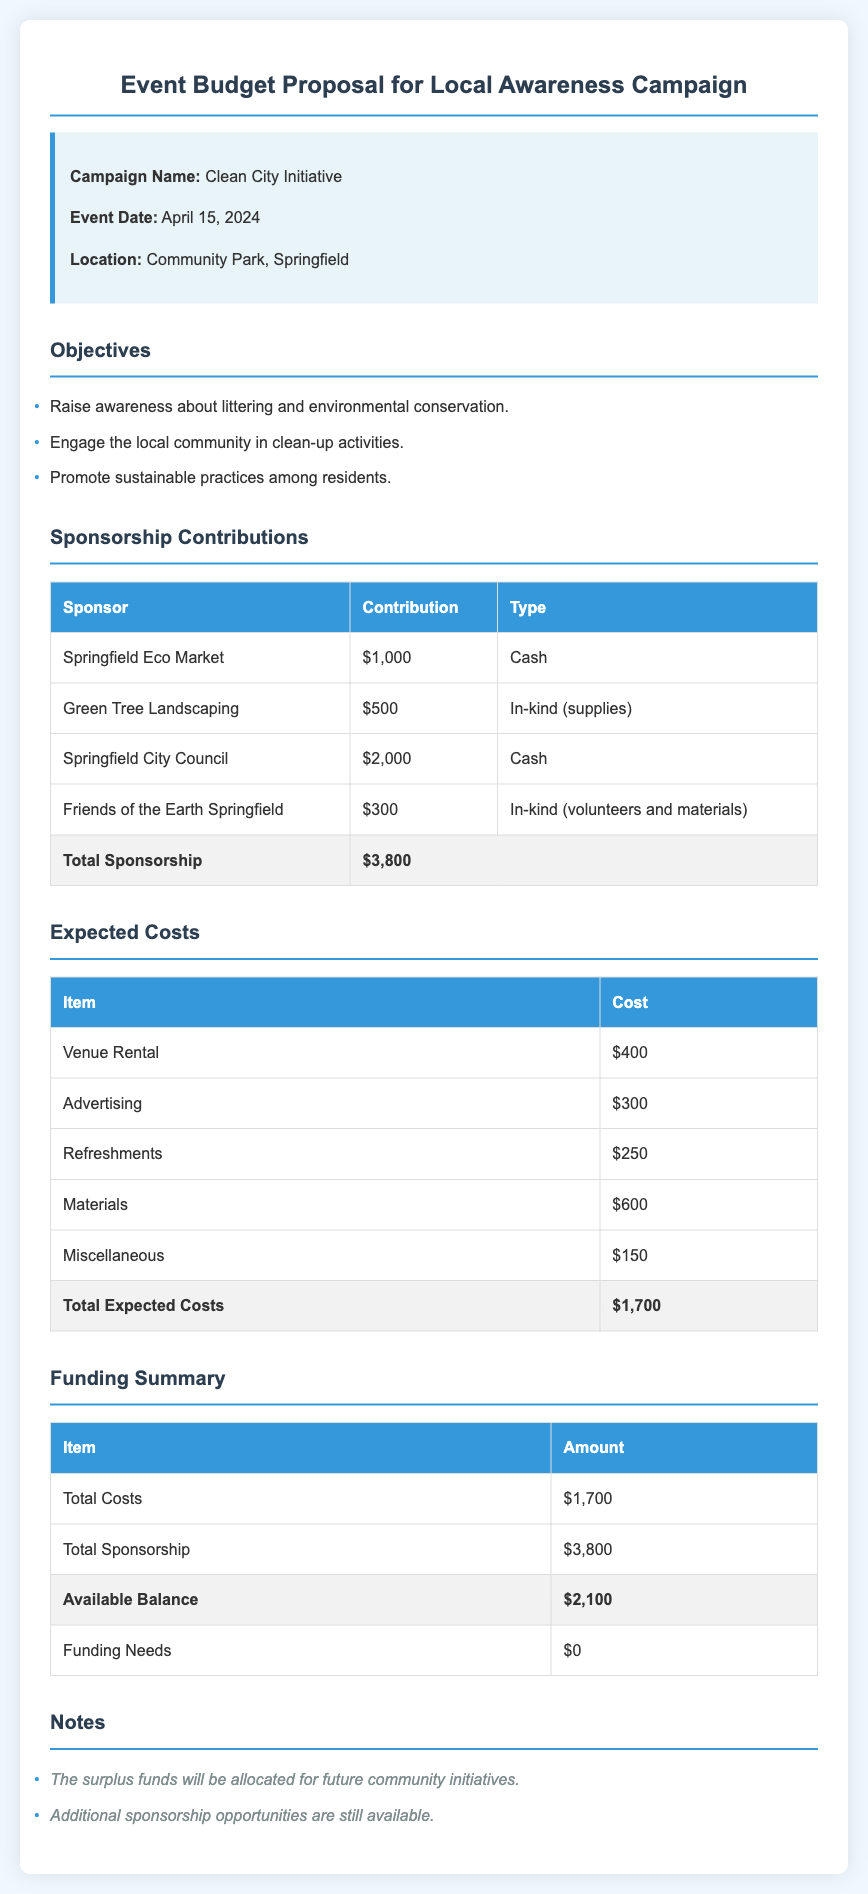What is the campaign name? The campaign name is specified in the document under the 'Campaign Name' section.
Answer: Clean City Initiative What is the event date? The event date is listed clearly in the event details section.
Answer: April 15, 2024 Who contributed the most cash sponsorship? The cash contributions can be found in the 'Sponsorship Contributions' table; the largest contributor can be identified by comparing the amounts.
Answer: Springfield City Council What is the cost of refreshments? The cost of refreshments is detailed in the 'Expected Costs' table, showing itemized expenses.
Answer: $250 What is the total sponsorship amount? The total sponsorship amount is the sum of all contributions listed in the 'Sponsorship Contributions' table.
Answer: $3,800 What are the total expected costs? The total expected costs are calculated from the sum of all items in the 'Expected Costs' table.
Answer: $1,700 Is there any funding need for this event? The funding needs can be found in the 'Funding Summary' table, showing the difference in costs and sponsorships.
Answer: $0 What will the surplus funds be used for? The usage of surplus funds is noted in the 'Notes' section of the document.
Answer: Future community initiatives What type of materials did Friends of the Earth Springfield provide? The type of contribution from Friends of the Earth Springfield is specified in the 'Sponsorship Contributions' table under the contribution type.
Answer: In-kind (volunteers and materials) 